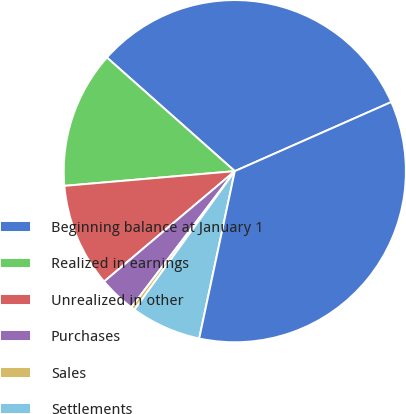<chart> <loc_0><loc_0><loc_500><loc_500><pie_chart><fcel>Beginning balance at January 1<fcel>Realized in earnings<fcel>Unrealized in other<fcel>Purchases<fcel>Sales<fcel>Settlements<fcel>Balance at December 31<nl><fcel>31.82%<fcel>12.93%<fcel>9.79%<fcel>3.5%<fcel>0.36%<fcel>6.64%<fcel>34.96%<nl></chart> 